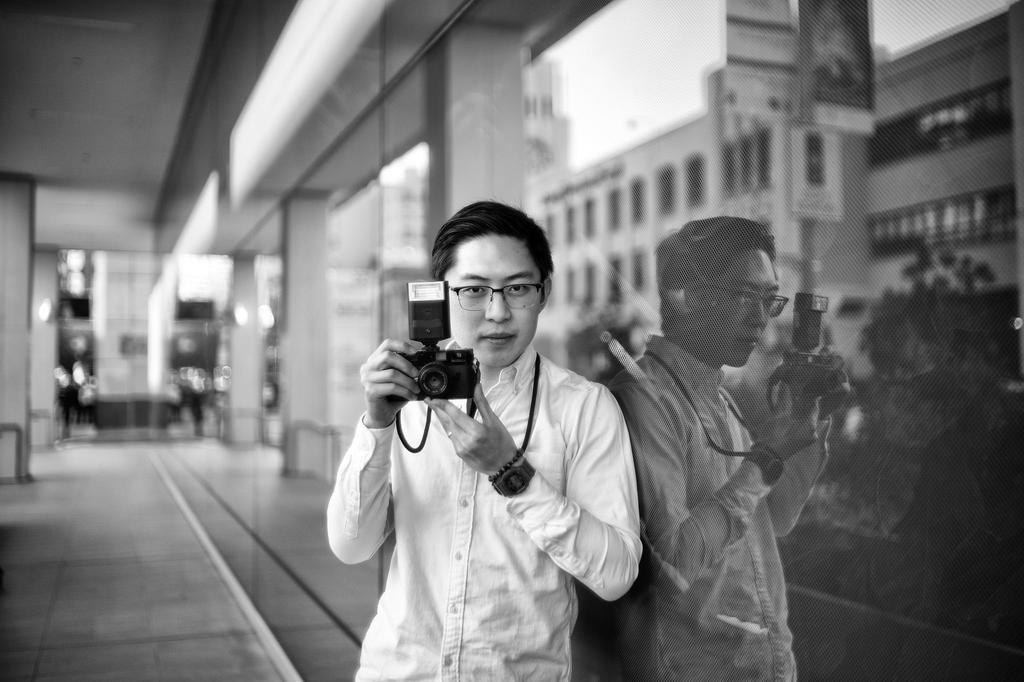Please provide a concise description of this image. This picture shows a man standing and holding a camera in his hands and we see a building and a plant 